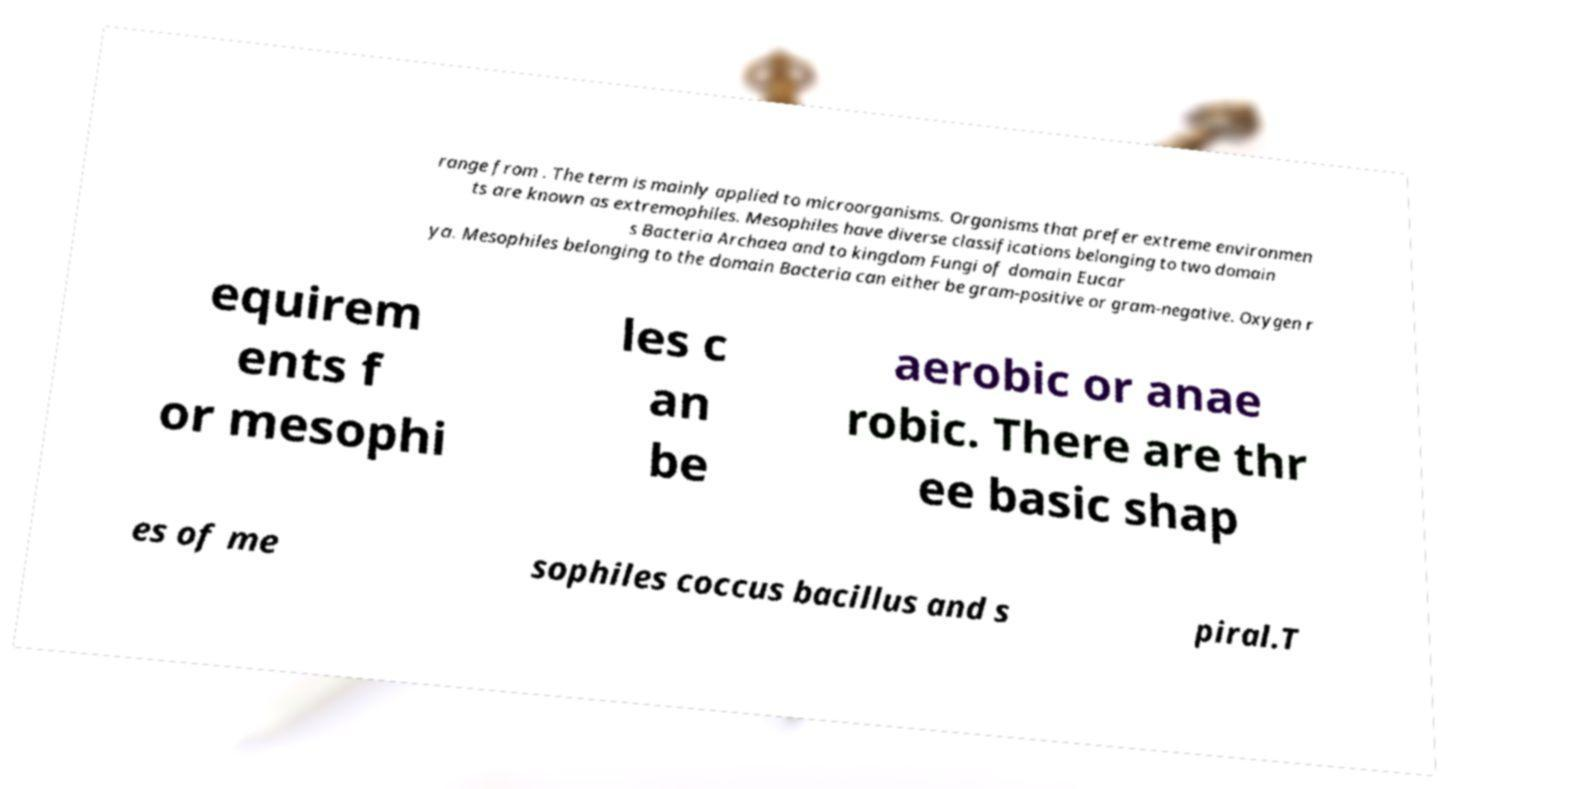What messages or text are displayed in this image? I need them in a readable, typed format. range from . The term is mainly applied to microorganisms. Organisms that prefer extreme environmen ts are known as extremophiles. Mesophiles have diverse classifications belonging to two domain s Bacteria Archaea and to kingdom Fungi of domain Eucar ya. Mesophiles belonging to the domain Bacteria can either be gram-positive or gram-negative. Oxygen r equirem ents f or mesophi les c an be aerobic or anae robic. There are thr ee basic shap es of me sophiles coccus bacillus and s piral.T 